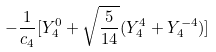<formula> <loc_0><loc_0><loc_500><loc_500>- \frac { 1 } { c _ { 4 } } [ Y _ { 4 } ^ { 0 } + \sqrt { \frac { 5 } { 1 4 } } ( Y _ { 4 } ^ { 4 } + Y _ { 4 } ^ { - 4 } ) ]</formula> 